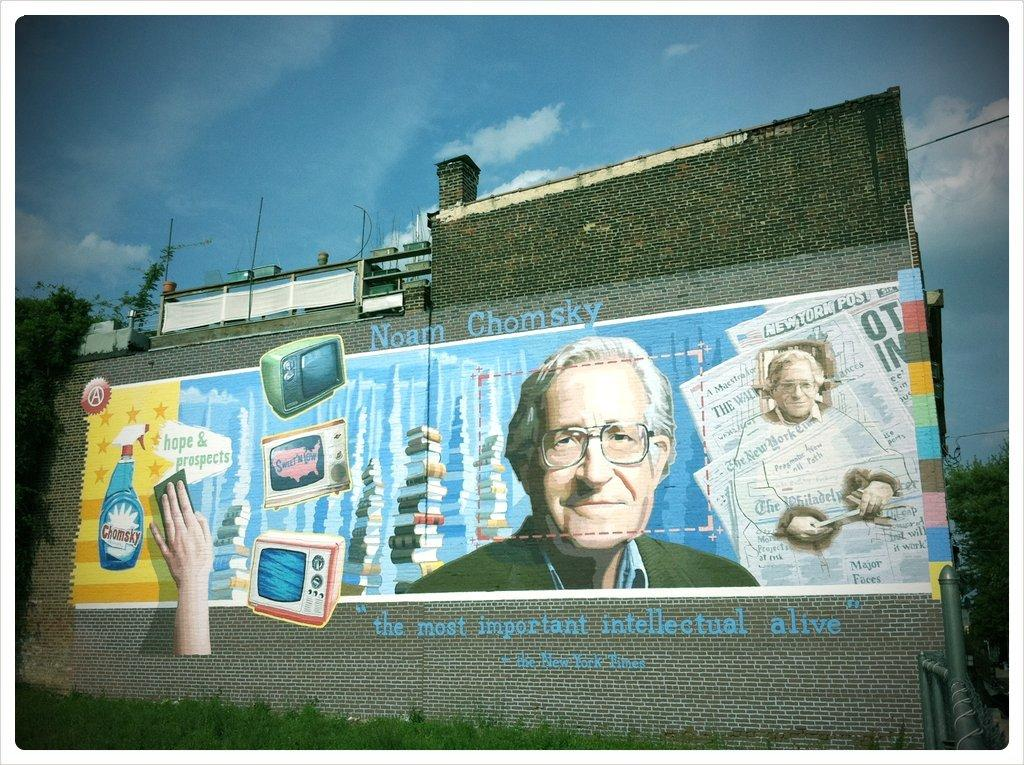<image>
Provide a brief description of the given image. the side of a building that says 'noam chomsky' on it 